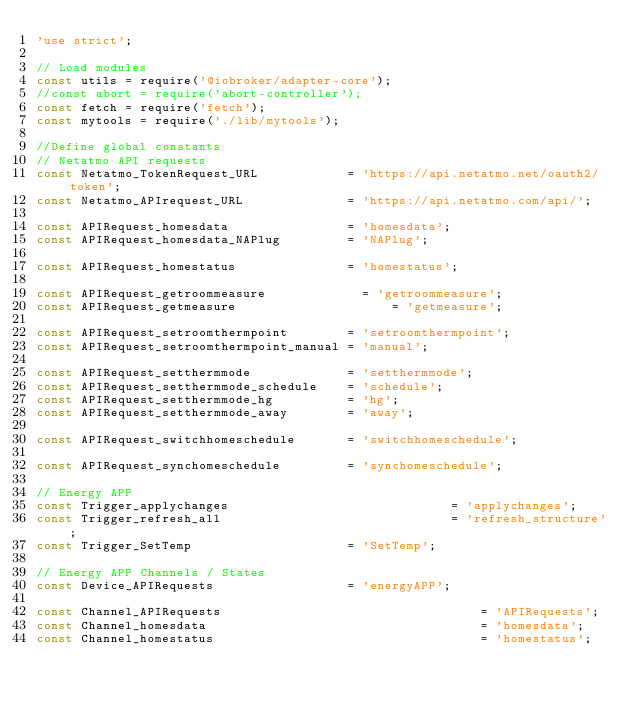<code> <loc_0><loc_0><loc_500><loc_500><_JavaScript_>'use strict';

// Load modules
const utils = require('@iobroker/adapter-core');
//const abort = require('abort-controller');
const fetch = require('fetch');
const mytools = require('./lib/mytools');

//Define global constants
// Netatmo API requests
const Netatmo_TokenRequest_URL            = 'https://api.netatmo.net/oauth2/token';
const Netatmo_APIrequest_URL              = 'https://api.netatmo.com/api/';

const APIRequest_homesdata                = 'homesdata';
const APIRequest_homesdata_NAPlug         = 'NAPlug';

const APIRequest_homestatus               = 'homestatus';

const APIRequest_getroommeasure		        = 'getroommeasure';
const APIRequest_getmeasure				        = 'getmeasure';

const APIRequest_setroomthermpoint        = 'setroomthermpoint';
const APIRequest_setroomthermpoint_manual = 'manual';

const APIRequest_setthermmode             = 'setthermmode';
const APIRequest_setthermmode_schedule    = 'schedule';
const APIRequest_setthermmode_hg          = 'hg';
const APIRequest_setthermmode_away        = 'away';

const APIRequest_switchhomeschedule       = 'switchhomeschedule';

const APIRequest_synchomeschedule         = 'synchomeschedule';

// Energy APP
const Trigger_applychanges								= 'applychanges';
const Trigger_refresh_all 								= 'refresh_structure';
const Trigger_SetTemp                     = 'SetTemp';

// Energy APP Channels / States
const Device_APIRequests                  = 'energyAPP';

const Channel_APIRequests									= 'APIRequests';
const Channel_homesdata										= 'homesdata';
const Channel_homestatus									= 'homestatus';</code> 